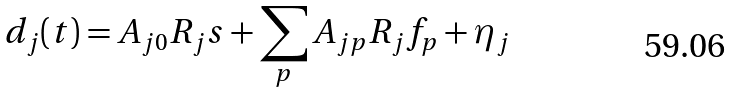Convert formula to latex. <formula><loc_0><loc_0><loc_500><loc_500>d _ { j } ( t ) = A _ { j 0 } R _ { j } s + \sum _ { p } A _ { j p } R _ { j } f _ { p } + \eta _ { j }</formula> 